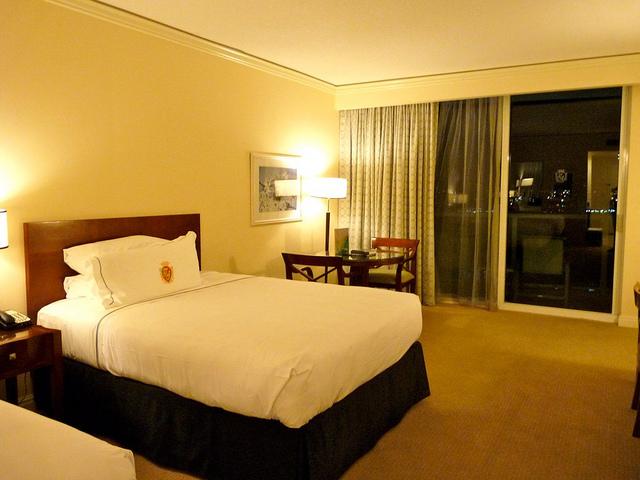How many beds in the room?
Be succinct. 1. Is this room on the ground floor?
Give a very brief answer. No. Is this room in a hotel?
Quick response, please. Yes. How many pillows are on the bed?
Short answer required. 3. Who is in the bed?
Write a very short answer. No one. How many objects are hanging on the wall?
Be succinct. 1. 